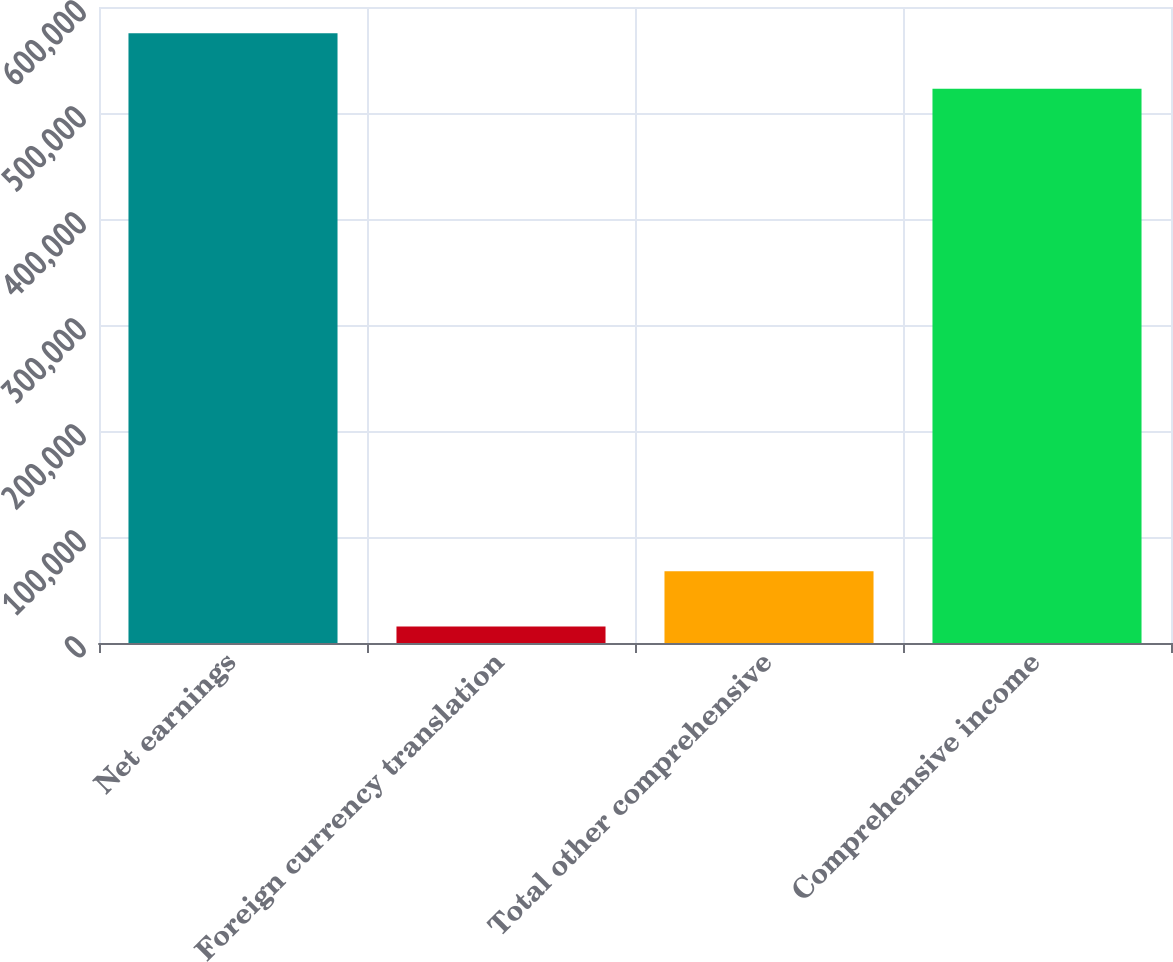Convert chart. <chart><loc_0><loc_0><loc_500><loc_500><bar_chart><fcel>Net earnings<fcel>Foreign currency translation<fcel>Total other comprehensive<fcel>Comprehensive income<nl><fcel>575123<fcel>15454<fcel>67737.9<fcel>522839<nl></chart> 